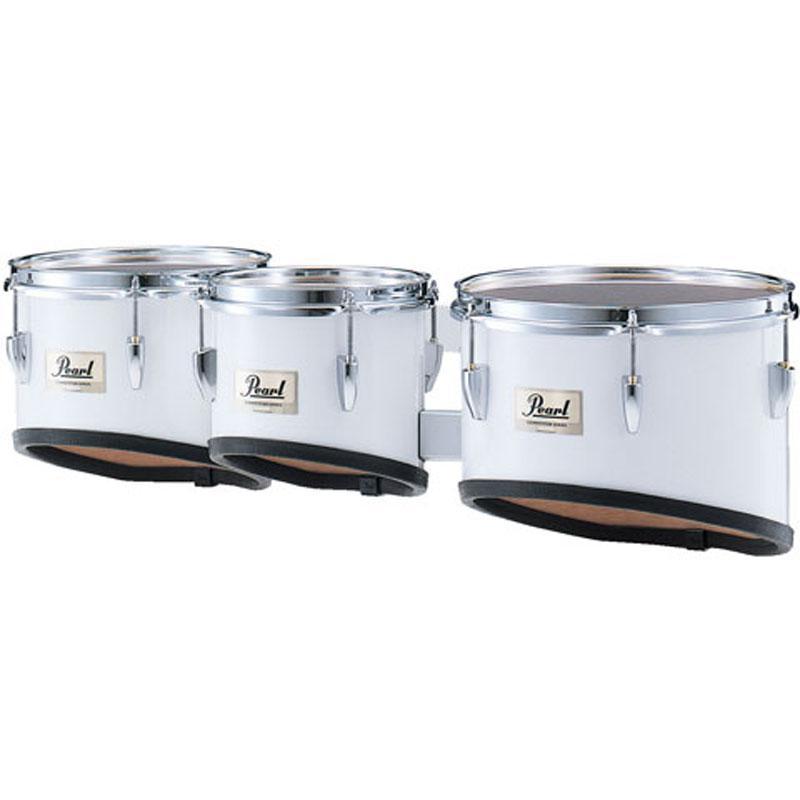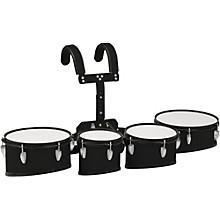The first image is the image on the left, the second image is the image on the right. Examine the images to the left and right. Is the description "The drum base is white in the left image." accurate? Answer yes or no. Yes. The first image is the image on the left, the second image is the image on the right. For the images displayed, is the sentence "At least one kit contains more than four drums." factually correct? Answer yes or no. No. 